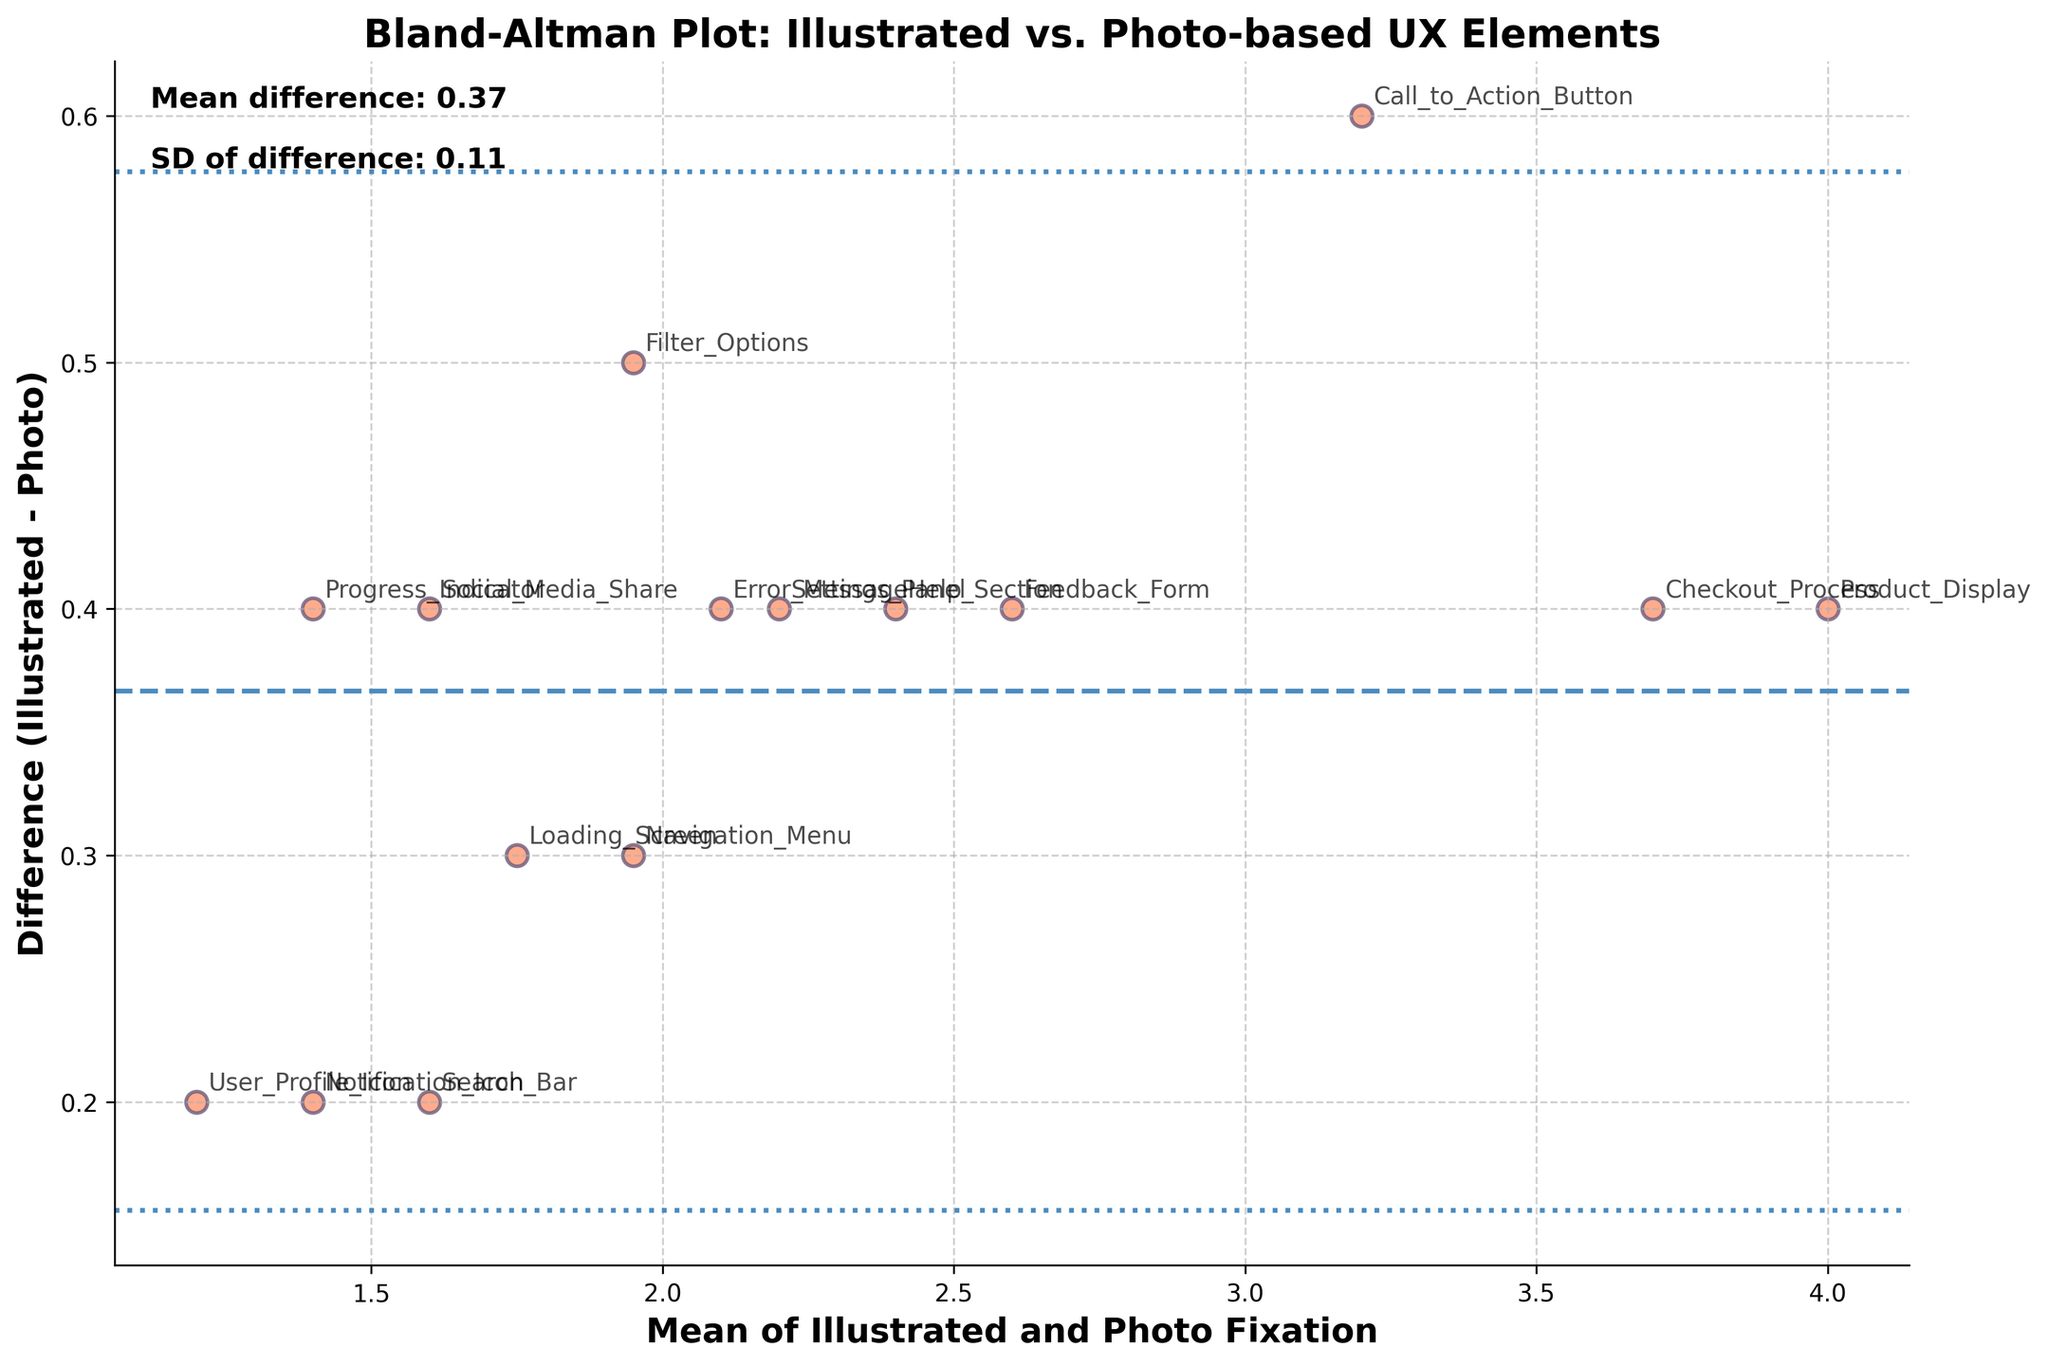What is the purpose of the Bland-Altman plot? The Bland-Altman plot is used to compare two different measurement methods by plotting their differences against their averages. It helps in visualizing agreement between the two methods and identifying any systematic biases.
Answer: Compare methods What is the title of the plot? The title of the plot can be found at the top of the figure and it reads 'Bland-Altman Plot: Illustrated vs. Photo-based UX Elements'.
Answer: Bland-Altman Plot: Illustrated vs. Photo-based UX Elements What color is used for the scatter points in the plot? The scatter points in the plot are colored in a shade of orange.
Answer: Orange How many data points are displayed on the plot? The number of data points can be counted by counting each scatter plot point. There are data points for each UX element being compared.
Answer: 15 What are the labels for the x-axis and y-axis? The labels for the x-axis and y-axis describe the data being represented. The x-axis is labeled 'Mean of Illustrated and Photo Fixation', and the y-axis is labeled 'Difference (Illustrated - Photo)'.
Answer: Mean of Illustrated and Photo Fixation; Difference (Illustrated - Photo) What is the mean difference value represented by the horizontal dashed line? The mean difference value is indicated by the position of the horizontal dashed line and is also annotated on the plot. It is the average of the differences between the illustrated and photo fixation data.
Answer: 0.38 What are the upper and lower limits of agreement? The upper and lower limits of agreement are shown by the horizontal dotted lines. These lines are placed at mean difference + 1.96*SD and mean difference - 1.96*SD, respectively. The exact value is also noted in the plot annotations.
Answer: 1.13; -0.37 Which UX element has the largest positive difference between illustrated and photo-based fixation duration? To find the largest positive difference, look for the highest point on the plot along the y-axis. The UX element that corresponds to this point can be identified by its label.
Answer: Product_Display Are there more data points with positive or negative differences? By observing the scatter points, count how many are above the mean line (positive differences) and how many are below it (negative differences).
Answer: More positive How does the fixation duration for the 'Call_to_Action_Button' compare between illustrated and photo-based UX elements? Find the data point labeled 'Call_to_Action_Button' and observe its position relative to the mean line. It is above the mean line, indicating a positive difference. This means the illustrated UX element has a longer fixation duration compared to the photo-based one.
Answer: Illustrated is longer 